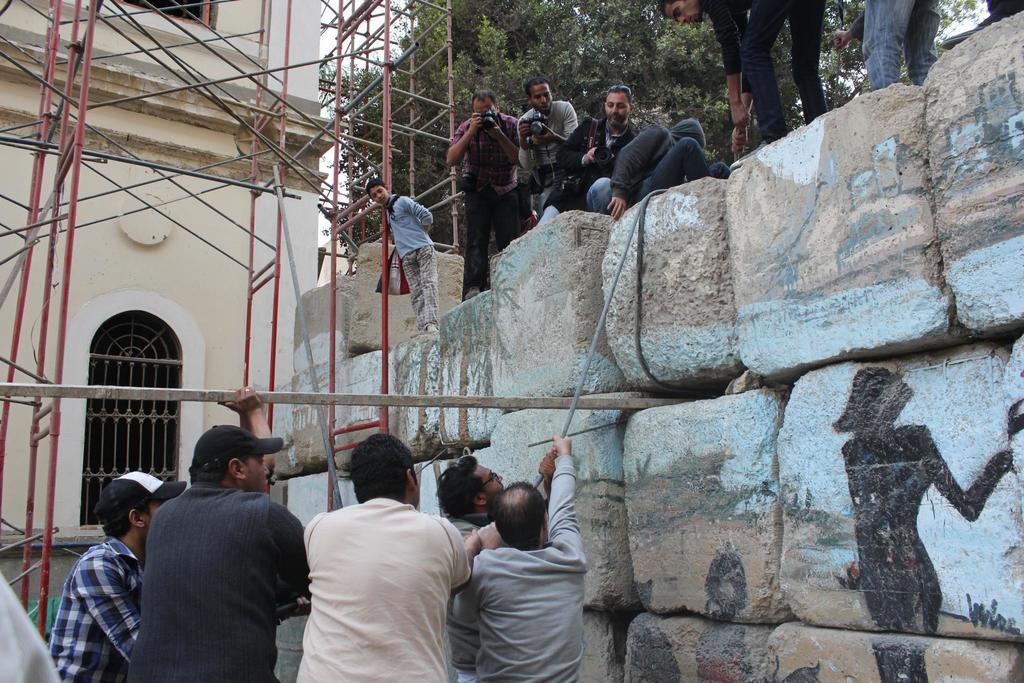In one or two sentences, can you explain what this image depicts? In the picture we can see five people are standing and three persons are holding a rope which is from the wall and on the wall we can see two people are standing with camera and capturing them and two people are holding the rope and besides them we can see a building wall with construction sticks around it and beside it we can see a part of the tree. 